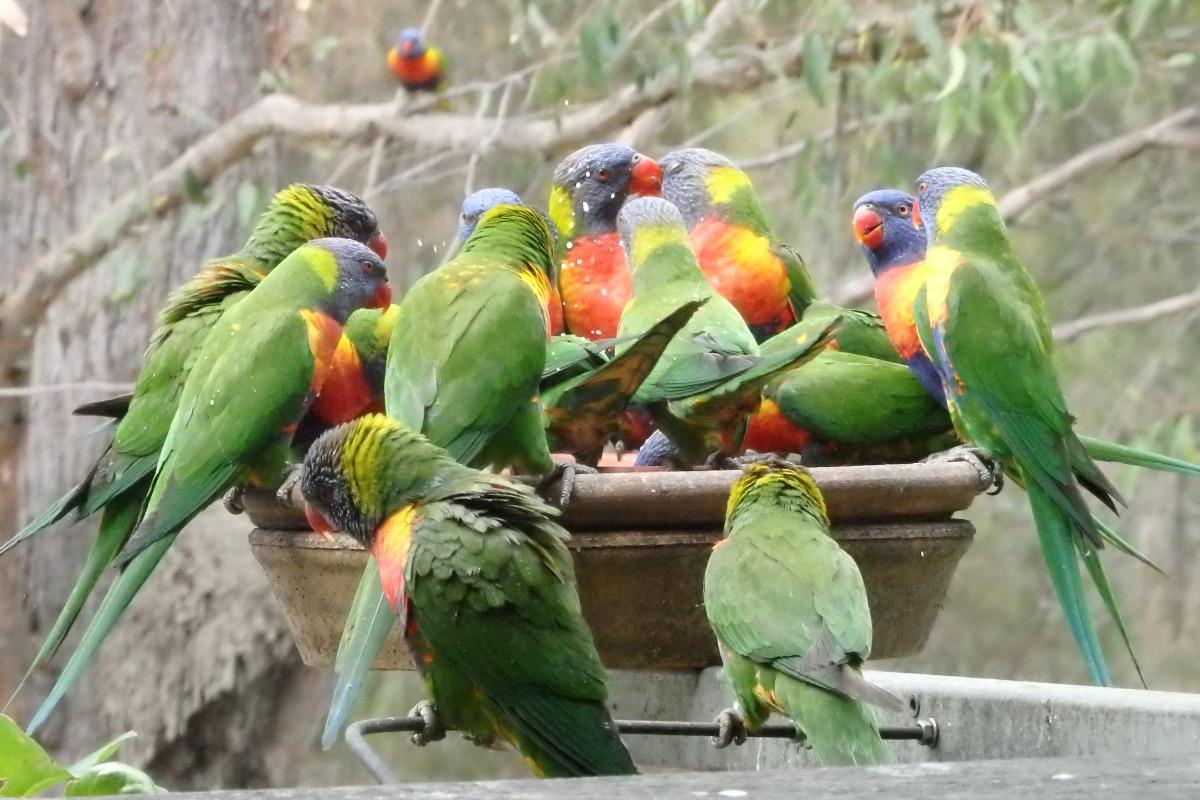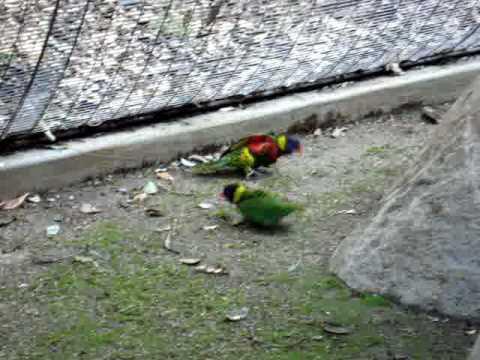The first image is the image on the left, the second image is the image on the right. For the images shown, is this caption "In at least one of the images there are four or more rainbow lorikeets gathered together." true? Answer yes or no. Yes. The first image is the image on the left, the second image is the image on the right. Evaluate the accuracy of this statement regarding the images: "There is at most four rainbow lorikeets.". Is it true? Answer yes or no. No. 